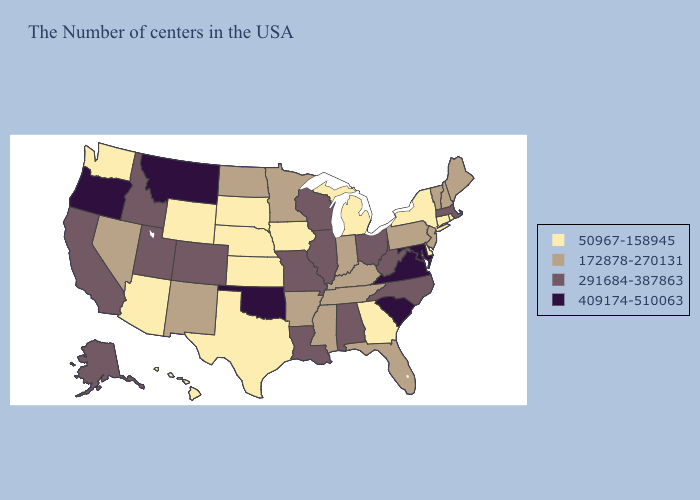What is the highest value in states that border New Hampshire?
Be succinct. 291684-387863. What is the highest value in the MidWest ?
Concise answer only. 291684-387863. Which states hav the highest value in the Northeast?
Concise answer only. Massachusetts. Name the states that have a value in the range 409174-510063?
Be succinct. Maryland, Virginia, South Carolina, Oklahoma, Montana, Oregon. Among the states that border Minnesota , does Wisconsin have the lowest value?
Short answer required. No. Is the legend a continuous bar?
Be succinct. No. Which states have the lowest value in the MidWest?
Give a very brief answer. Michigan, Iowa, Kansas, Nebraska, South Dakota. What is the highest value in the USA?
Answer briefly. 409174-510063. Does New Mexico have a higher value than South Dakota?
Short answer required. Yes. What is the value of South Carolina?
Quick response, please. 409174-510063. Does the map have missing data?
Keep it brief. No. How many symbols are there in the legend?
Quick response, please. 4. Name the states that have a value in the range 50967-158945?
Write a very short answer. Rhode Island, Connecticut, New York, Delaware, Georgia, Michigan, Iowa, Kansas, Nebraska, Texas, South Dakota, Wyoming, Arizona, Washington, Hawaii. Name the states that have a value in the range 409174-510063?
Keep it brief. Maryland, Virginia, South Carolina, Oklahoma, Montana, Oregon. Does the first symbol in the legend represent the smallest category?
Quick response, please. Yes. 